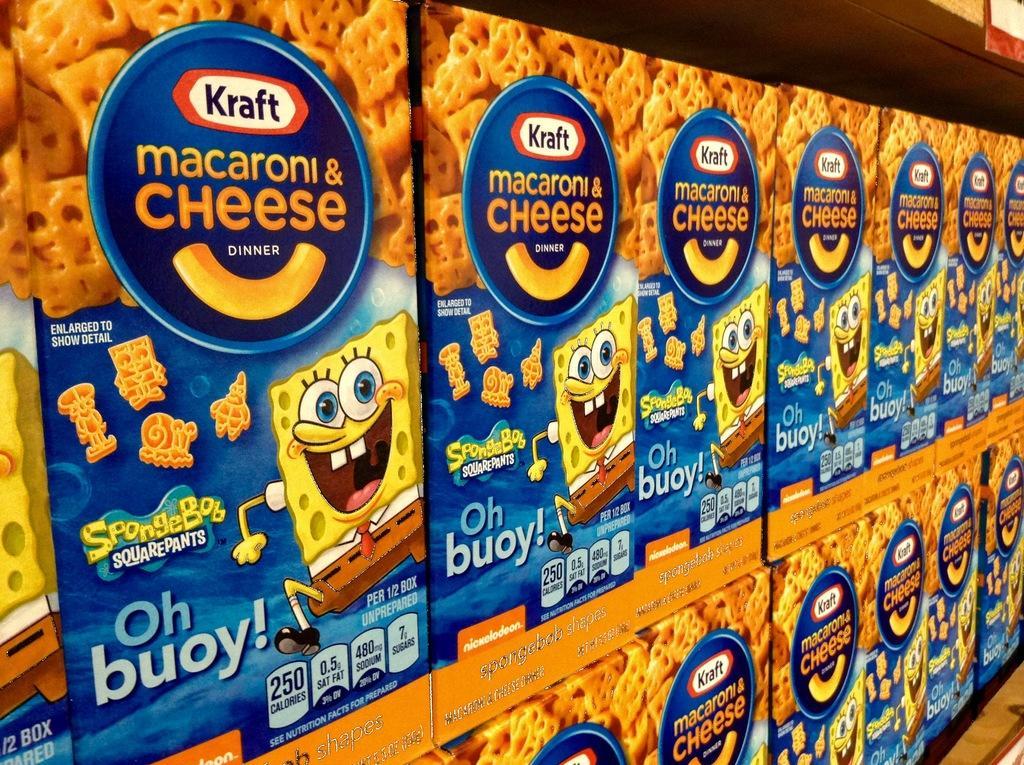Describe this image in one or two sentences. In the image we can see there are many boxes kept on the shelf. On the box there is a picture of a cartoon, printed text and food item. 